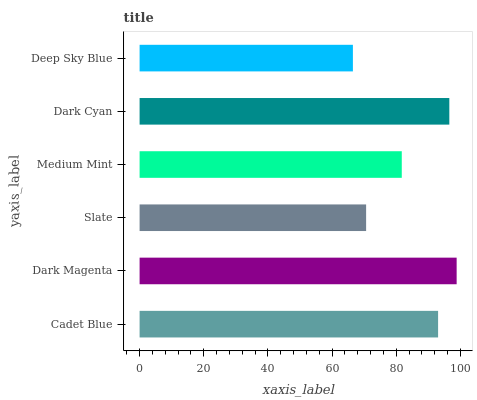Is Deep Sky Blue the minimum?
Answer yes or no. Yes. Is Dark Magenta the maximum?
Answer yes or no. Yes. Is Slate the minimum?
Answer yes or no. No. Is Slate the maximum?
Answer yes or no. No. Is Dark Magenta greater than Slate?
Answer yes or no. Yes. Is Slate less than Dark Magenta?
Answer yes or no. Yes. Is Slate greater than Dark Magenta?
Answer yes or no. No. Is Dark Magenta less than Slate?
Answer yes or no. No. Is Cadet Blue the high median?
Answer yes or no. Yes. Is Medium Mint the low median?
Answer yes or no. Yes. Is Slate the high median?
Answer yes or no. No. Is Dark Magenta the low median?
Answer yes or no. No. 